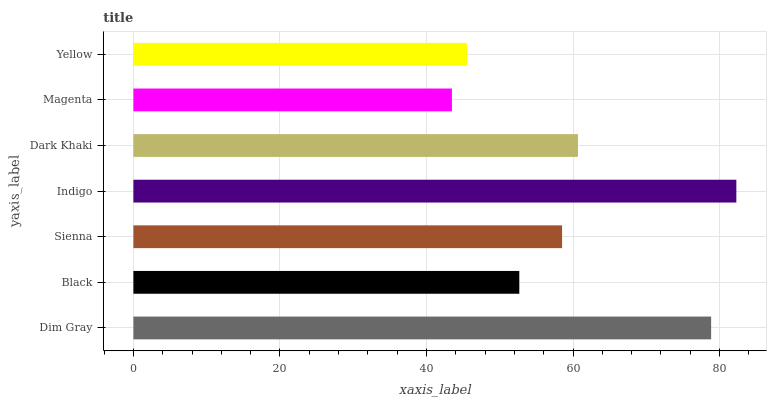Is Magenta the minimum?
Answer yes or no. Yes. Is Indigo the maximum?
Answer yes or no. Yes. Is Black the minimum?
Answer yes or no. No. Is Black the maximum?
Answer yes or no. No. Is Dim Gray greater than Black?
Answer yes or no. Yes. Is Black less than Dim Gray?
Answer yes or no. Yes. Is Black greater than Dim Gray?
Answer yes or no. No. Is Dim Gray less than Black?
Answer yes or no. No. Is Sienna the high median?
Answer yes or no. Yes. Is Sienna the low median?
Answer yes or no. Yes. Is Dark Khaki the high median?
Answer yes or no. No. Is Dim Gray the low median?
Answer yes or no. No. 